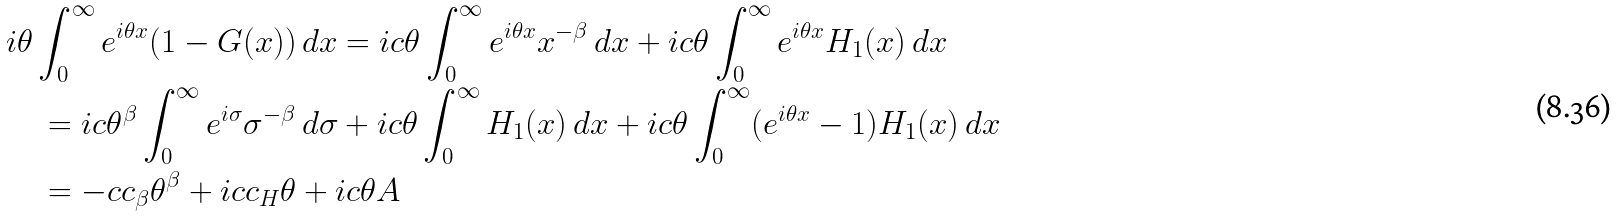<formula> <loc_0><loc_0><loc_500><loc_500>& i \theta \int _ { 0 } ^ { \infty } e ^ { i \theta x } ( 1 - G ( x ) ) \, d x = i c \theta \int _ { 0 } ^ { \infty } e ^ { i \theta x } x ^ { - \beta } \, d x + i c \theta \int _ { 0 } ^ { \infty } e ^ { i \theta x } H _ { 1 } ( x ) \, d x \\ & \quad = i c \theta ^ { \beta } \int _ { 0 } ^ { \infty } e ^ { i \sigma } \sigma ^ { - \beta } \, d \sigma + i c \theta \int _ { 0 } ^ { \infty } H _ { 1 } ( x ) \, d x + i c \theta \int _ { 0 } ^ { \infty } ( e ^ { i \theta x } - 1 ) H _ { 1 } ( x ) \, d x \\ & \quad = - c c _ { \beta } \theta ^ { \beta } + i c c _ { H } \theta + i c \theta A</formula> 